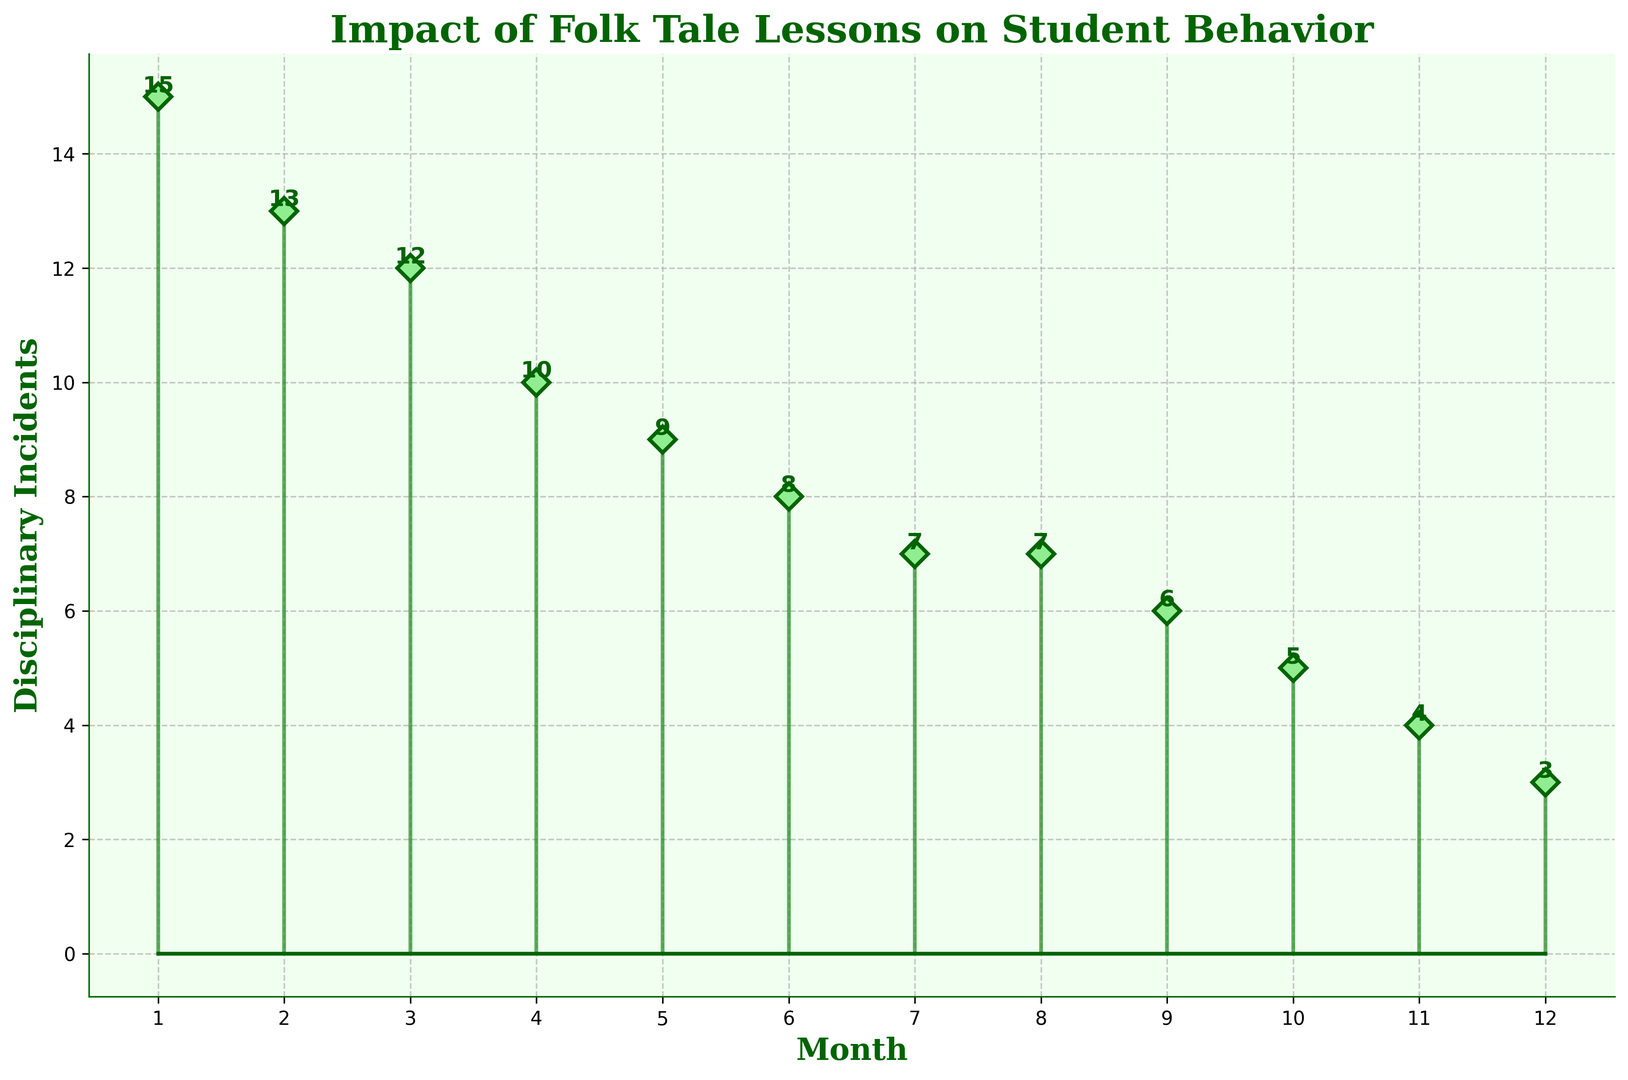What is the total number of disciplinary incidents over the year? Sum all the incidents from each month (15 + 13 + 12 + 10 + 9 + 8 + 7 + 7 + 6 + 5 + 4 + 3 = 99).
Answer: 99 Which month had the highest number of disciplinary incidents? Look at the figure and identify the month with the peak stem, which is the tallest marker.
Answer: January What is the difference in the number of disciplinary incidents between January and December? Subtract the number of incidents in December from those in January (15 - 3).
Answer: 12 How does the number of disciplinary incidents in April compare to May? Compare the heights of the markers for April and May. April has 10 incidents and May has 9, so April is higher.
Answer: April By how many incidents do the number of disciplinary incidents decrease from July to December? Find the difference between July and December's incidents (7 - 3).
Answer: 4 What is the average number of disciplinary incidents per month across the year? Calculate the total number of incidents divided by 12 months (99 / 12).
Answer: 8.25 Which two consecutive months have the smallest change in disciplinary incidents? Identify the months with the smallest vertical difference between their markers. The smallest change is between July and August (7 to 7, so 0).
Answer: July and August What visual attributes indicate the decreasing trend of disciplinary incidents over the months? Notice the declining height of the green markers and stems from left (January) to right (December). Also, the numerical labels on each marker decrease sequentially.
Answer: Height and numerical labels Is there any month where the number of incidents remained the same as the previous month? Identify any months where the heights and numerical labels of markers remain consistent with the previous one, which occurs from July to August (both months have 7).
Answer: Yes, July and August 